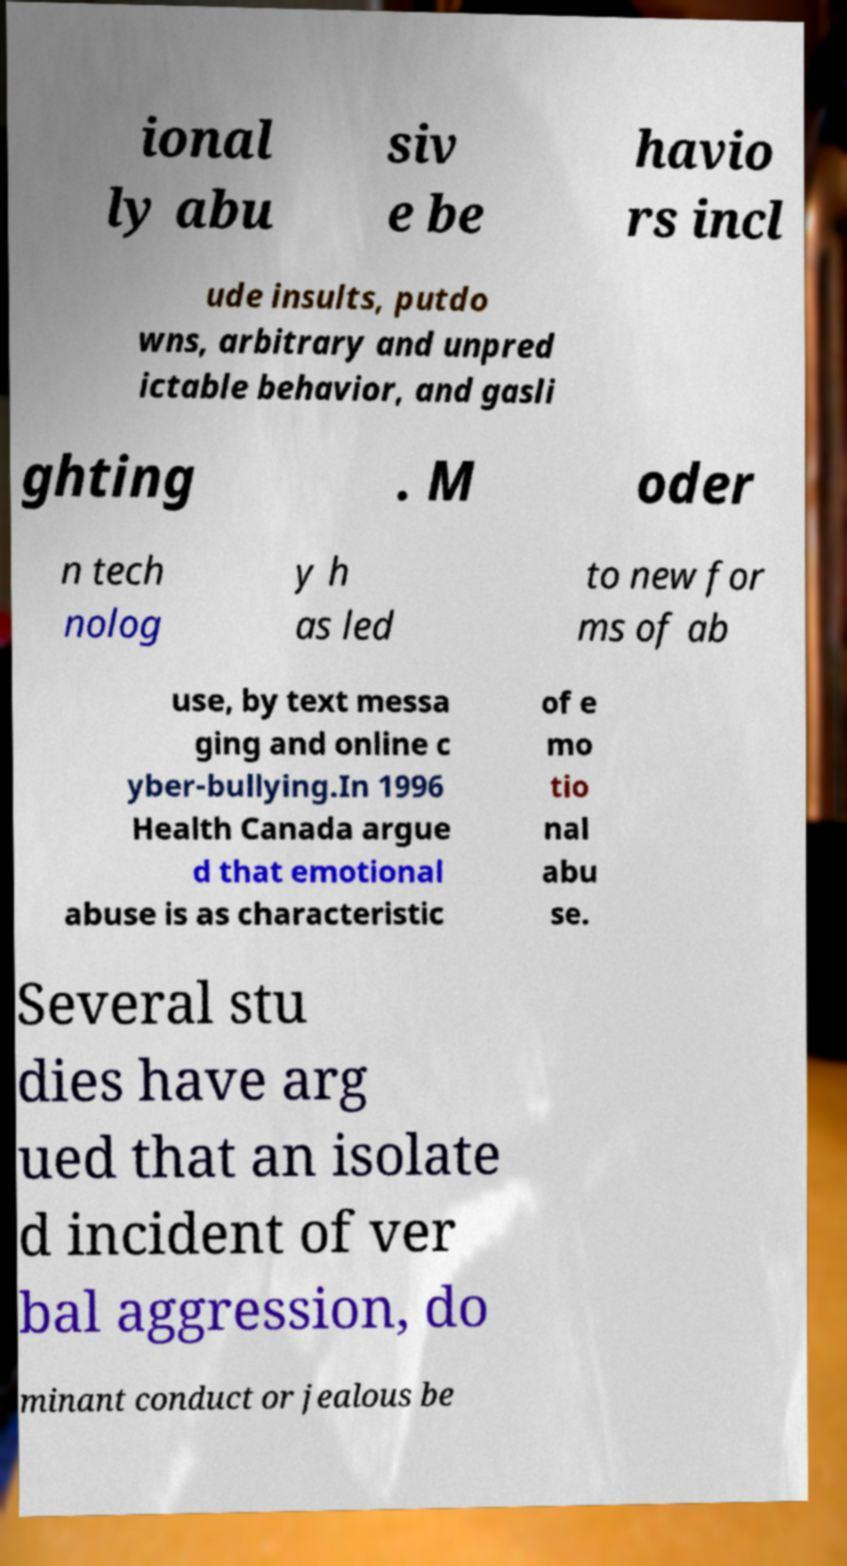There's text embedded in this image that I need extracted. Can you transcribe it verbatim? ional ly abu siv e be havio rs incl ude insults, putdo wns, arbitrary and unpred ictable behavior, and gasli ghting . M oder n tech nolog y h as led to new for ms of ab use, by text messa ging and online c yber-bullying.In 1996 Health Canada argue d that emotional abuse is as characteristic of e mo tio nal abu se. Several stu dies have arg ued that an isolate d incident of ver bal aggression, do minant conduct or jealous be 